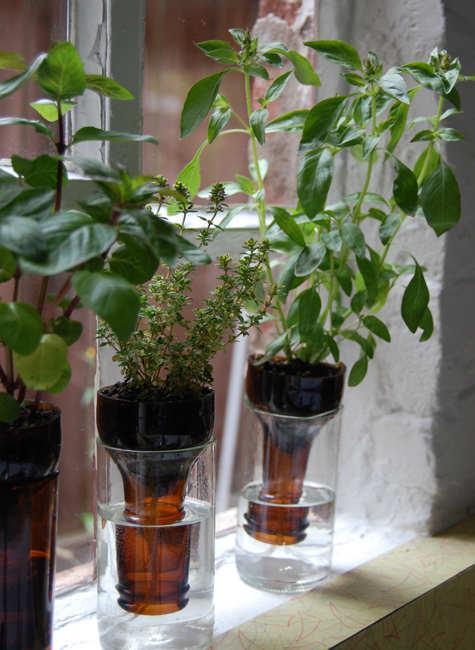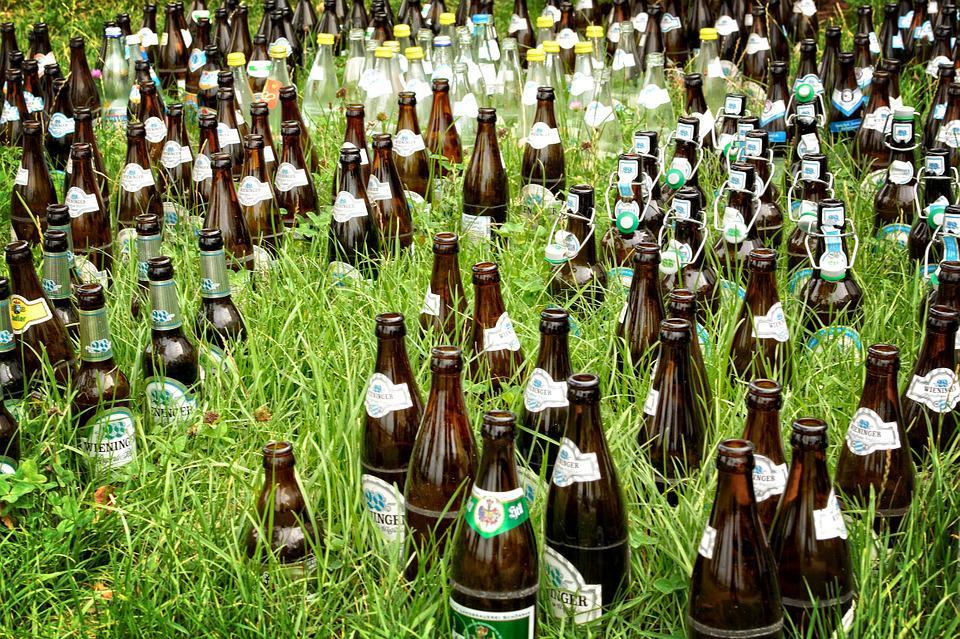The first image is the image on the left, the second image is the image on the right. Given the left and right images, does the statement "A single bottle in the image on the right is positioned upside down." hold true? Answer yes or no. No. 